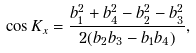Convert formula to latex. <formula><loc_0><loc_0><loc_500><loc_500>\cos K _ { x } = \frac { b _ { 1 } ^ { 2 } + b _ { 4 } ^ { 2 } - b _ { 2 } ^ { 2 } - b _ { 3 } ^ { 2 } } { 2 ( b _ { 2 } b _ { 3 } - b _ { 1 } b _ { 4 } ) } ,</formula> 